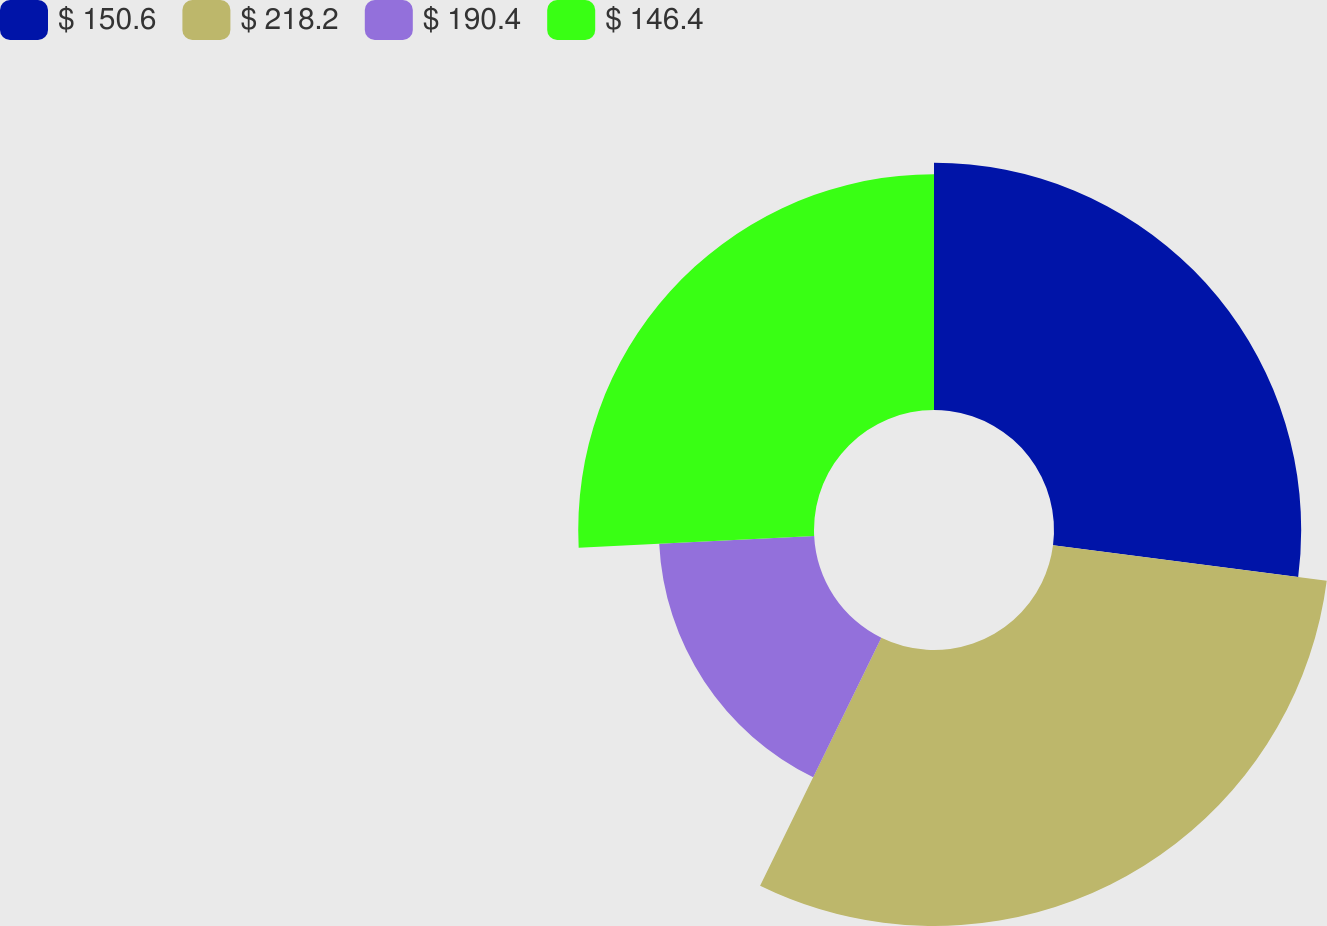Convert chart. <chart><loc_0><loc_0><loc_500><loc_500><pie_chart><fcel>$ 150.6<fcel>$ 218.2<fcel>$ 190.4<fcel>$ 146.4<nl><fcel>27.04%<fcel>30.19%<fcel>16.97%<fcel>25.79%<nl></chart> 